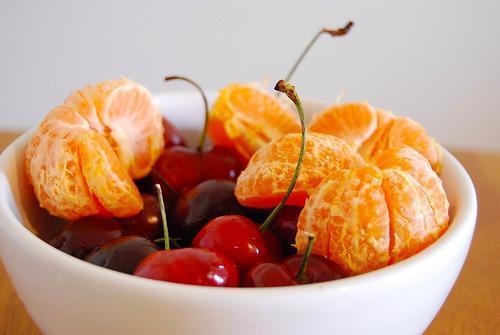How many oranges are in the photo?
Give a very brief answer. 3. How many round donuts have nuts on them in the image?
Give a very brief answer. 0. 